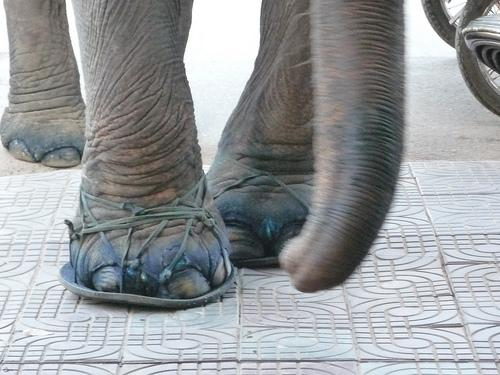Question: what animal is shown in this photo?
Choices:
A. Cow.
B. Elephant.
C. Dog.
D. Horse.
Answer with the letter. Answer: B Question: how many elephant trunks are in the photo?
Choices:
A. Two.
B. One.
C. Three.
D. Four.
Answer with the letter. Answer: B Question: how many of the elephants feet are visible in the photo?
Choices:
A. Three.
B. Five.
C. Six.
D. Seven.
Answer with the letter. Answer: A Question: what is the elephant walking on?
Choices:
A. Sand.
B. Tiled walkway.
C. Rocks.
D. Dirt.
Answer with the letter. Answer: B Question: what material is wrapped around two of the elephant's feet?
Choices:
A. Ribbon.
B. Chains.
C. Nylon.
D. String.
Answer with the letter. Answer: D Question: where is this scene taking place?
Choices:
A. At the garden.
B. At the prairie.
C. At the forest.
D. At a zoo.
Answer with the letter. Answer: D 